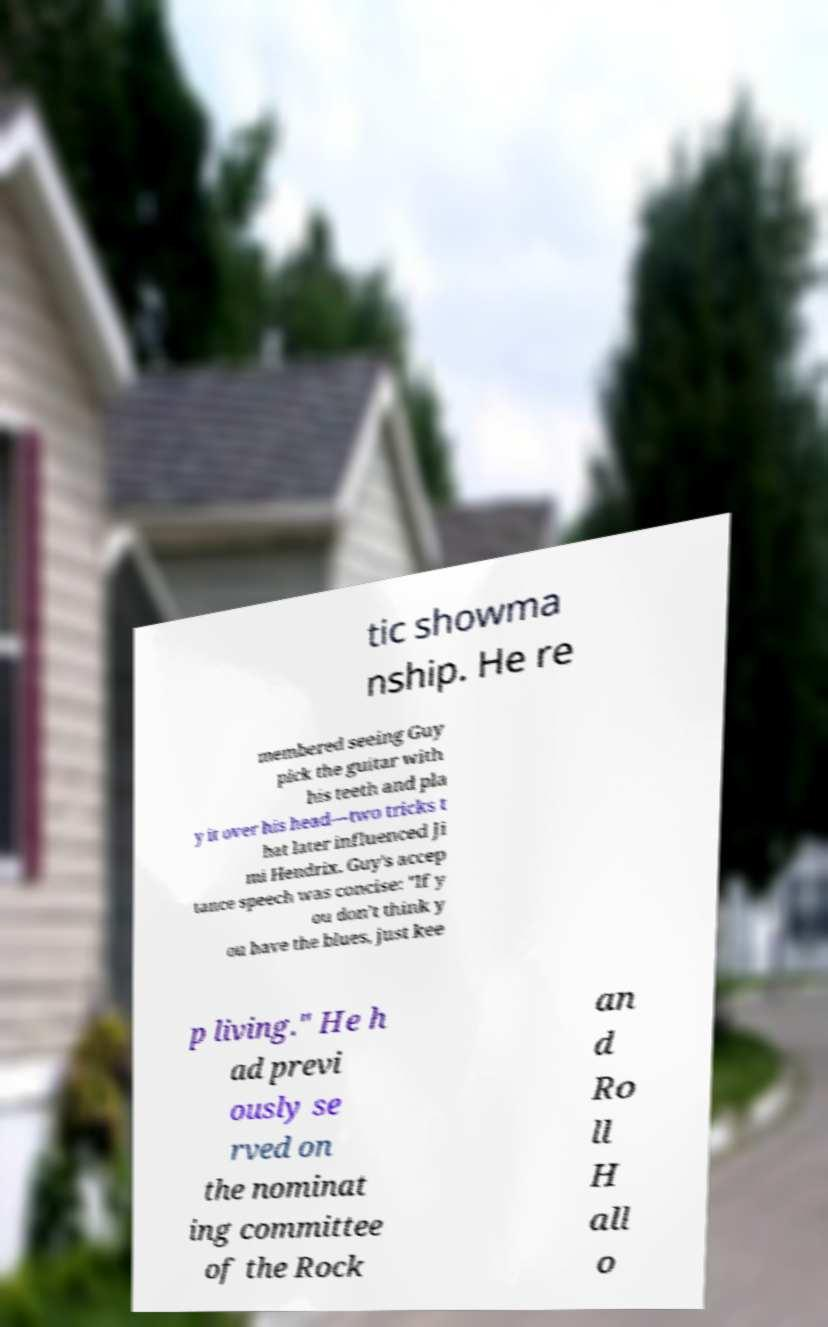There's text embedded in this image that I need extracted. Can you transcribe it verbatim? tic showma nship. He re membered seeing Guy pick the guitar with his teeth and pla y it over his head—two tricks t hat later influenced Ji mi Hendrix. Guy's accep tance speech was concise: "If y ou don’t think y ou have the blues, just kee p living." He h ad previ ously se rved on the nominat ing committee of the Rock an d Ro ll H all o 